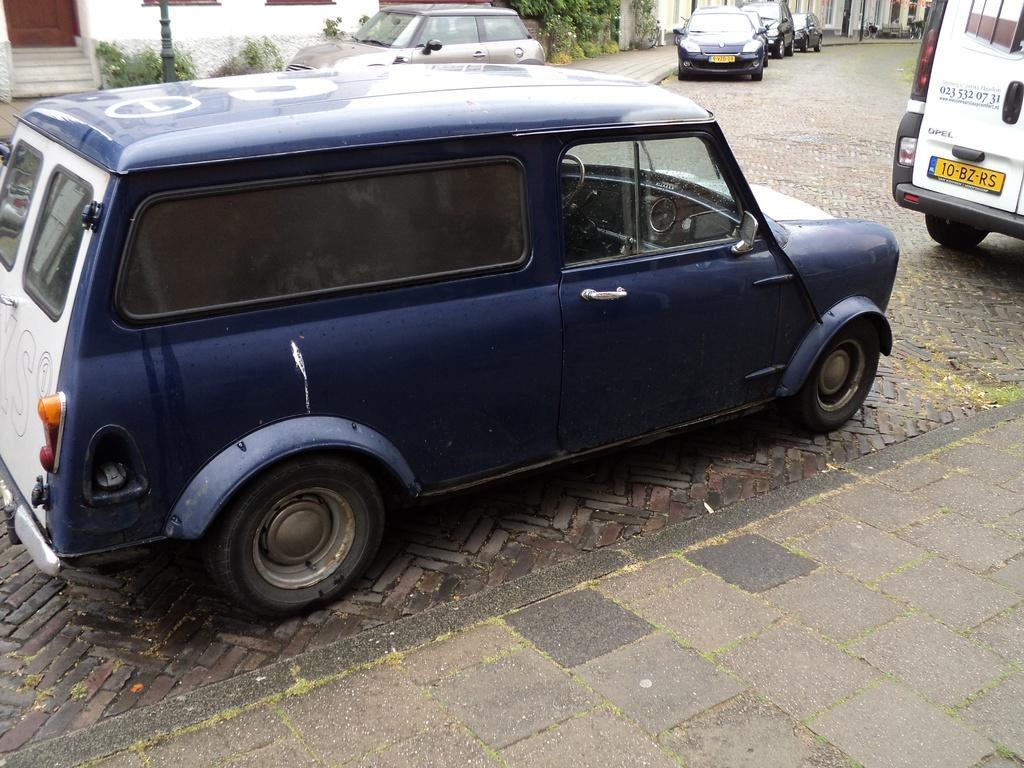What is present on the road in the image? There are vehicles on the road in the image. What can be seen behind the vehicles? Plants, poles, and buildings are visible behind the vehicles. Can you describe the surroundings of the vehicles in the image? The vehicles are surrounded by plants, poles, and buildings. What type of bean is being exchanged between the team members in the image? There is no team, exchange, or bean present in the image. 